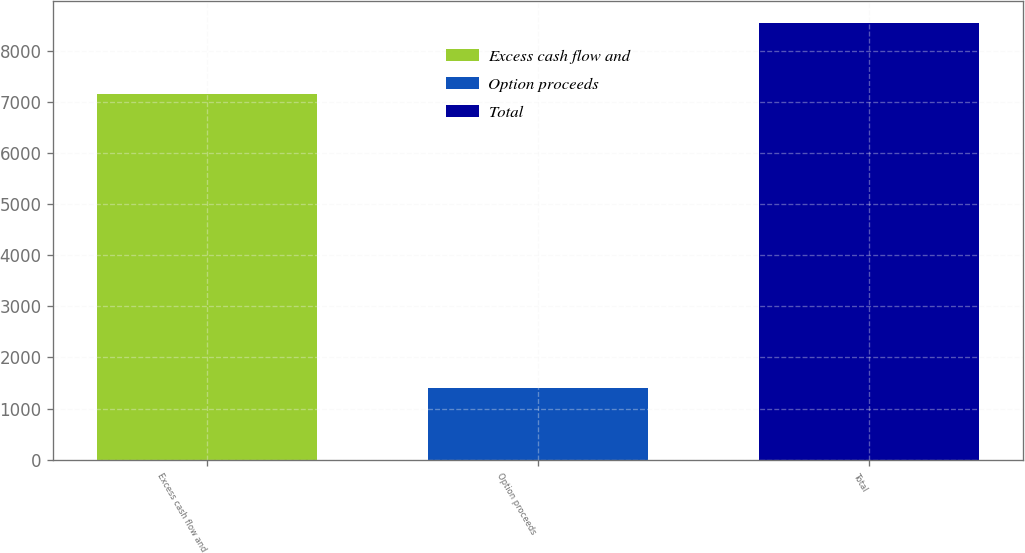Convert chart. <chart><loc_0><loc_0><loc_500><loc_500><bar_chart><fcel>Excess cash flow and<fcel>Option proceeds<fcel>Total<nl><fcel>7155<fcel>1394<fcel>8549<nl></chart> 